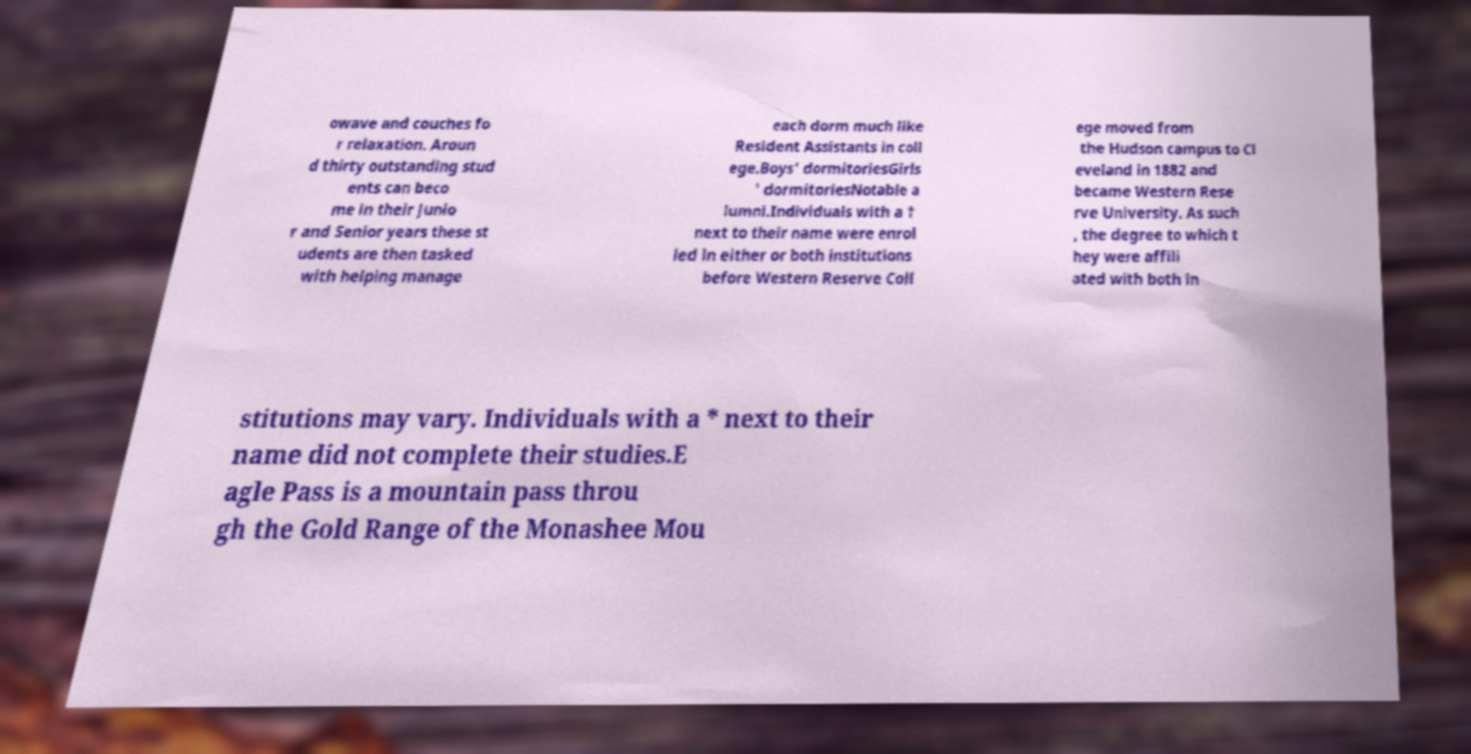What messages or text are displayed in this image? I need them in a readable, typed format. owave and couches fo r relaxation. Aroun d thirty outstanding stud ents can beco me in their Junio r and Senior years these st udents are then tasked with helping manage each dorm much like Resident Assistants in coll ege.Boys' dormitoriesGirls ' dormitoriesNotable a lumni.Individuals with a † next to their name were enrol led in either or both institutions before Western Reserve Coll ege moved from the Hudson campus to Cl eveland in 1882 and became Western Rese rve University. As such , the degree to which t hey were affili ated with both in stitutions may vary. Individuals with a * next to their name did not complete their studies.E agle Pass is a mountain pass throu gh the Gold Range of the Monashee Mou 